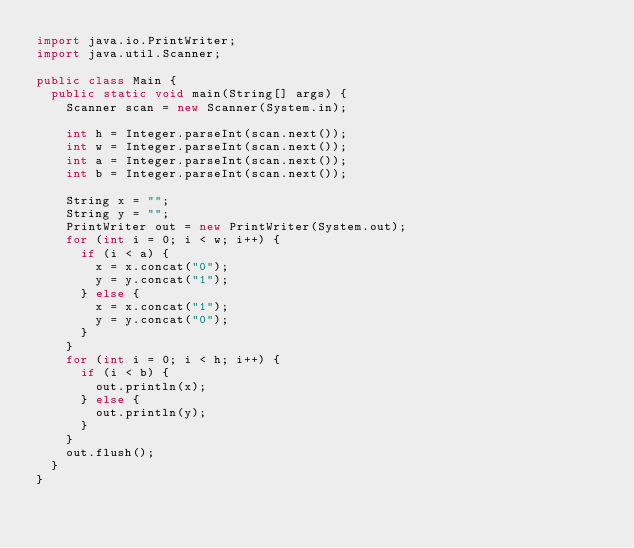<code> <loc_0><loc_0><loc_500><loc_500><_Java_>import java.io.PrintWriter;
import java.util.Scanner;

public class Main {
	public static void main(String[] args) {
		Scanner scan = new Scanner(System.in);

		int h = Integer.parseInt(scan.next());
		int w = Integer.parseInt(scan.next());
		int a = Integer.parseInt(scan.next());
		int b = Integer.parseInt(scan.next());

		String x = "";
		String y = "";
		PrintWriter out = new PrintWriter(System.out);
		for (int i = 0; i < w; i++) {
			if (i < a) {
				x = x.concat("0");
				y = y.concat("1");
			} else {
				x = x.concat("1");
				y = y.concat("0");
			}
		}
		for (int i = 0; i < h; i++) {
			if (i < b) {
				out.println(x);
			} else {
				out.println(y);
			}
		}
		out.flush();
	}
}</code> 